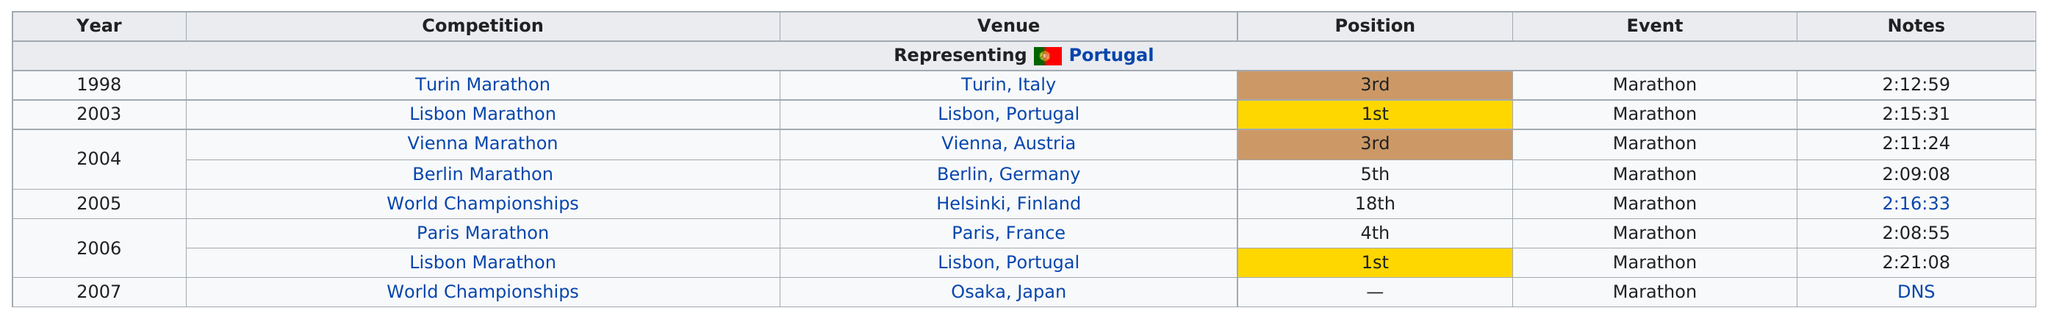Identify some key points in this picture. After the Turin Marathon, the next competition is the Lisbon Marathon. The last competition was the World Championships. In the year 2004, the third position was occupied by a year other than 1998. Luis Jesus' quickest finish time was 2 hours and 8 minutes and 55 seconds. The first year is 1998. 